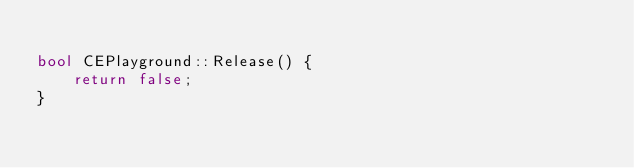<code> <loc_0><loc_0><loc_500><loc_500><_C++_>
bool CEPlayground::Release() {
	return false;
}
</code> 